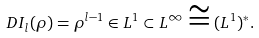<formula> <loc_0><loc_0><loc_500><loc_500>D I _ { l } ( \rho ) = \rho ^ { l - 1 } \in L ^ { 1 } \subset L ^ { \infty } \cong ( L ^ { 1 } ) ^ { \ast } .</formula> 